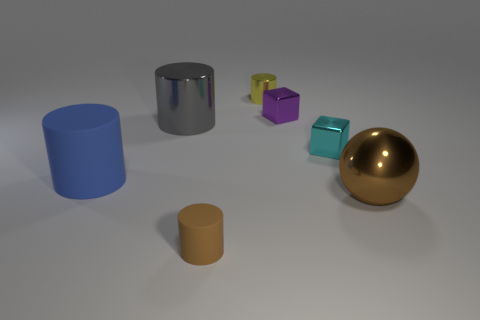What shape is the metal object that is both in front of the small yellow shiny cylinder and to the left of the purple cube?
Your answer should be very brief. Cylinder. Are any yellow objects visible?
Ensure brevity in your answer.  Yes. There is a blue thing that is the same shape as the large gray shiny object; what is its material?
Keep it short and to the point. Rubber. What shape is the small shiny thing in front of the big shiny object that is behind the matte thing behind the tiny brown cylinder?
Offer a very short reply. Cube. There is a small thing that is the same color as the big sphere; what material is it?
Your response must be concise. Rubber. What number of other large things are the same shape as the purple metallic thing?
Offer a very short reply. 0. There is a small cylinder in front of the yellow cylinder; is it the same color as the big shiny object to the right of the small matte object?
Give a very brief answer. Yes. What is the material of the cube that is the same size as the purple thing?
Provide a short and direct response. Metal. Is there a yellow rubber ball that has the same size as the gray metal cylinder?
Your answer should be compact. No. Are there fewer tiny metal objects in front of the tiny yellow cylinder than metal things?
Your answer should be very brief. Yes. 